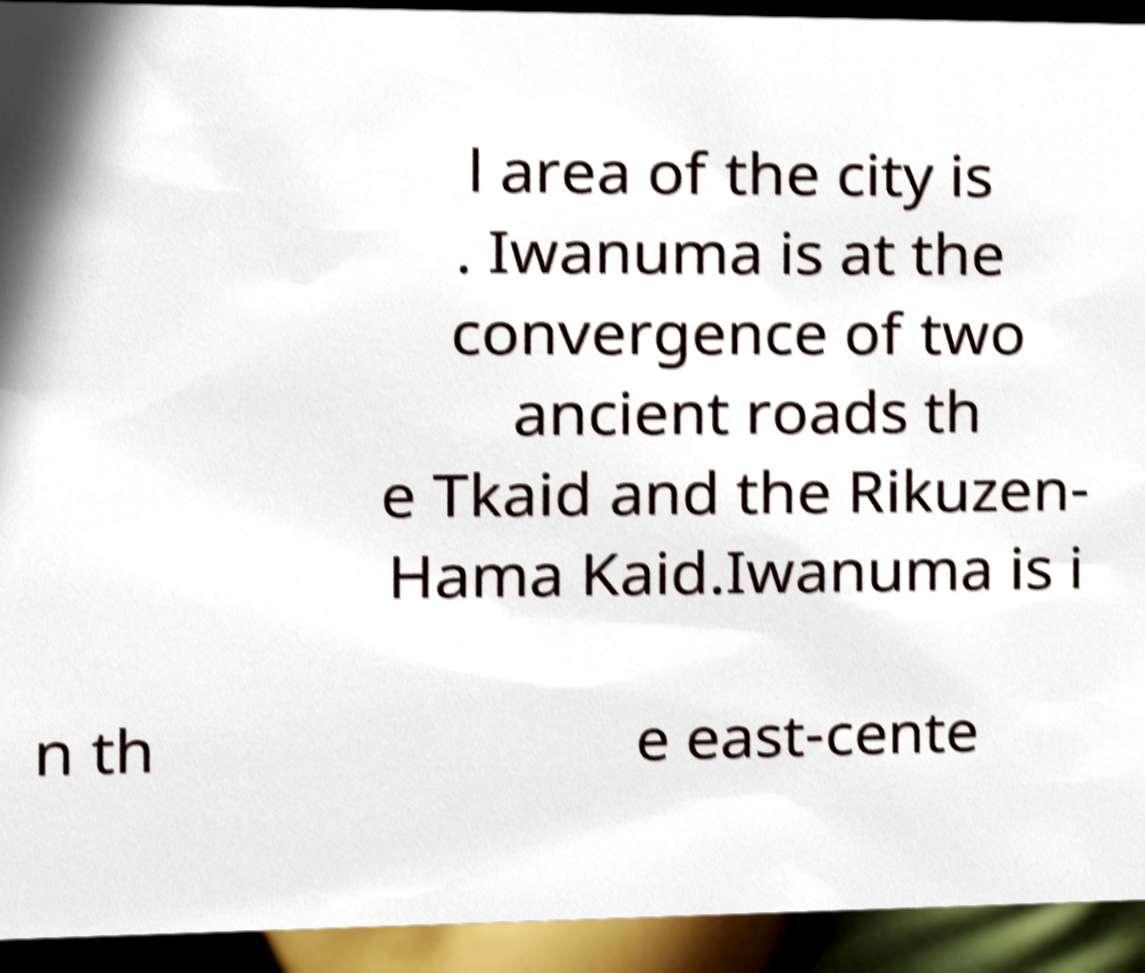Please identify and transcribe the text found in this image. l area of the city is . Iwanuma is at the convergence of two ancient roads th e Tkaid and the Rikuzen- Hama Kaid.Iwanuma is i n th e east-cente 